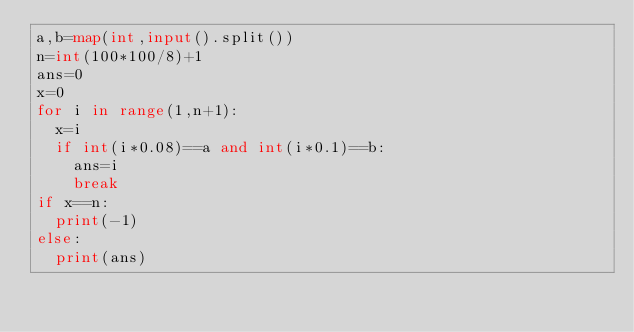Convert code to text. <code><loc_0><loc_0><loc_500><loc_500><_Python_>a,b=map(int,input().split())
n=int(100*100/8)+1
ans=0
x=0
for i in range(1,n+1):
  x=i
  if int(i*0.08)==a and int(i*0.1)==b:
    ans=i
    break
if x==n:
  print(-1)
else:
  print(ans)</code> 